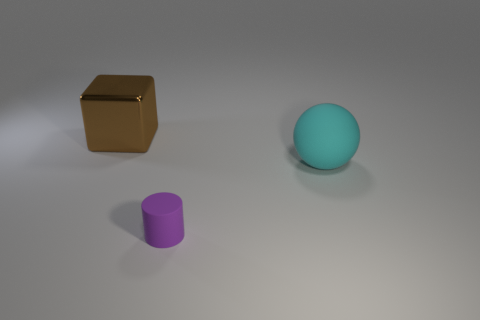Add 1 purple metal blocks. How many objects exist? 4 Subtract all balls. How many objects are left? 2 Subtract 0 brown cylinders. How many objects are left? 3 Subtract all brown cylinders. Subtract all big cyan objects. How many objects are left? 2 Add 3 big metal blocks. How many big metal blocks are left? 4 Add 3 tiny red matte blocks. How many tiny red matte blocks exist? 3 